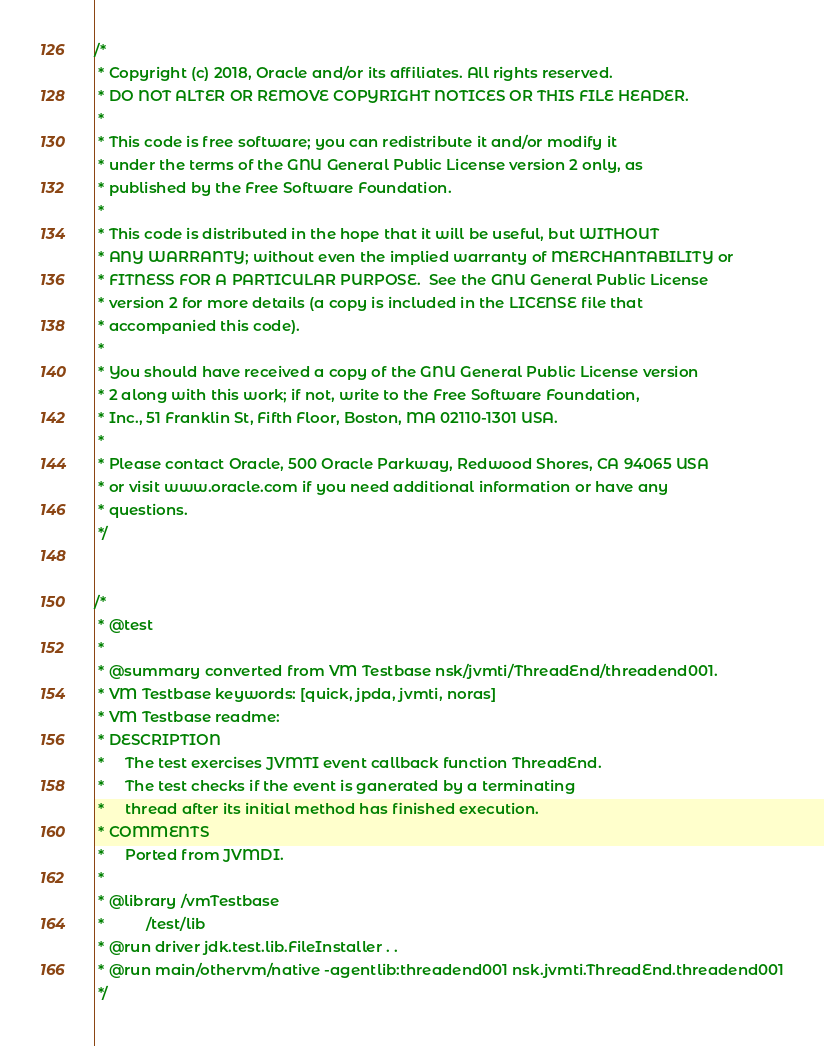Convert code to text. <code><loc_0><loc_0><loc_500><loc_500><_Java_>/*
 * Copyright (c) 2018, Oracle and/or its affiliates. All rights reserved.
 * DO NOT ALTER OR REMOVE COPYRIGHT NOTICES OR THIS FILE HEADER.
 *
 * This code is free software; you can redistribute it and/or modify it
 * under the terms of the GNU General Public License version 2 only, as
 * published by the Free Software Foundation.
 *
 * This code is distributed in the hope that it will be useful, but WITHOUT
 * ANY WARRANTY; without even the implied warranty of MERCHANTABILITY or
 * FITNESS FOR A PARTICULAR PURPOSE.  See the GNU General Public License
 * version 2 for more details (a copy is included in the LICENSE file that
 * accompanied this code).
 *
 * You should have received a copy of the GNU General Public License version
 * 2 along with this work; if not, write to the Free Software Foundation,
 * Inc., 51 Franklin St, Fifth Floor, Boston, MA 02110-1301 USA.
 *
 * Please contact Oracle, 500 Oracle Parkway, Redwood Shores, CA 94065 USA
 * or visit www.oracle.com if you need additional information or have any
 * questions.
 */


/*
 * @test
 *
 * @summary converted from VM Testbase nsk/jvmti/ThreadEnd/threadend001.
 * VM Testbase keywords: [quick, jpda, jvmti, noras]
 * VM Testbase readme:
 * DESCRIPTION
 *     The test exercises JVMTI event callback function ThreadEnd.
 *     The test checks if the event is ganerated by a terminating
 *     thread after its initial method has finished execution.
 * COMMENTS
 *     Ported from JVMDI.
 *
 * @library /vmTestbase
 *          /test/lib
 * @run driver jdk.test.lib.FileInstaller . .
 * @run main/othervm/native -agentlib:threadend001 nsk.jvmti.ThreadEnd.threadend001
 */

</code> 